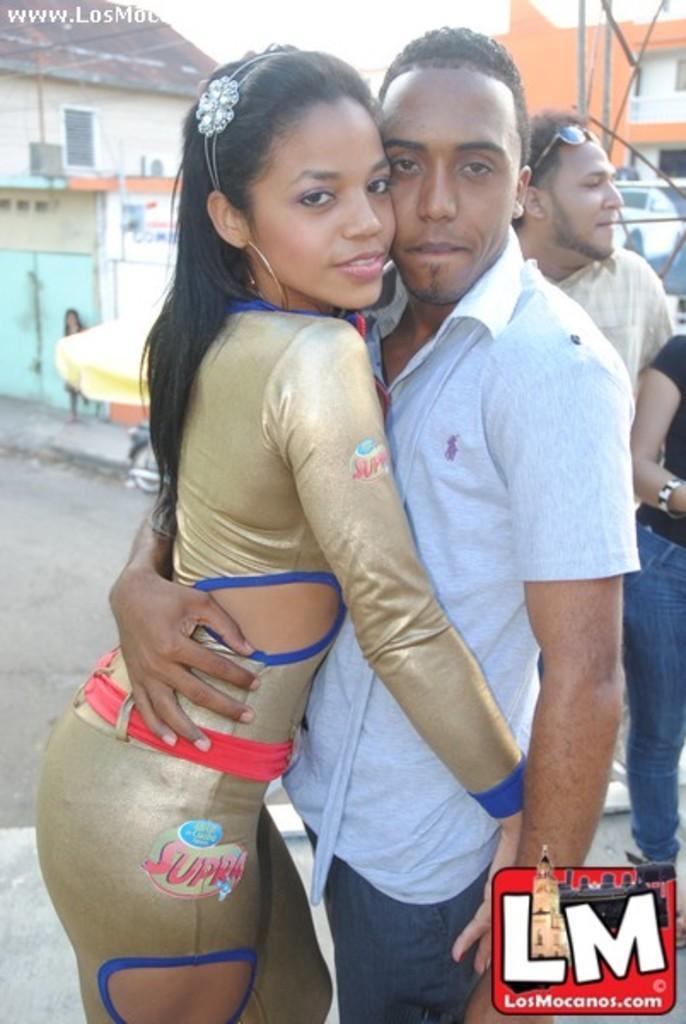How would you summarize this image in a sentence or two? In this image we can see there are two persons are hugged by each other, beside them there are another two persons looking to the left side of the image. In the background there are buildings. 